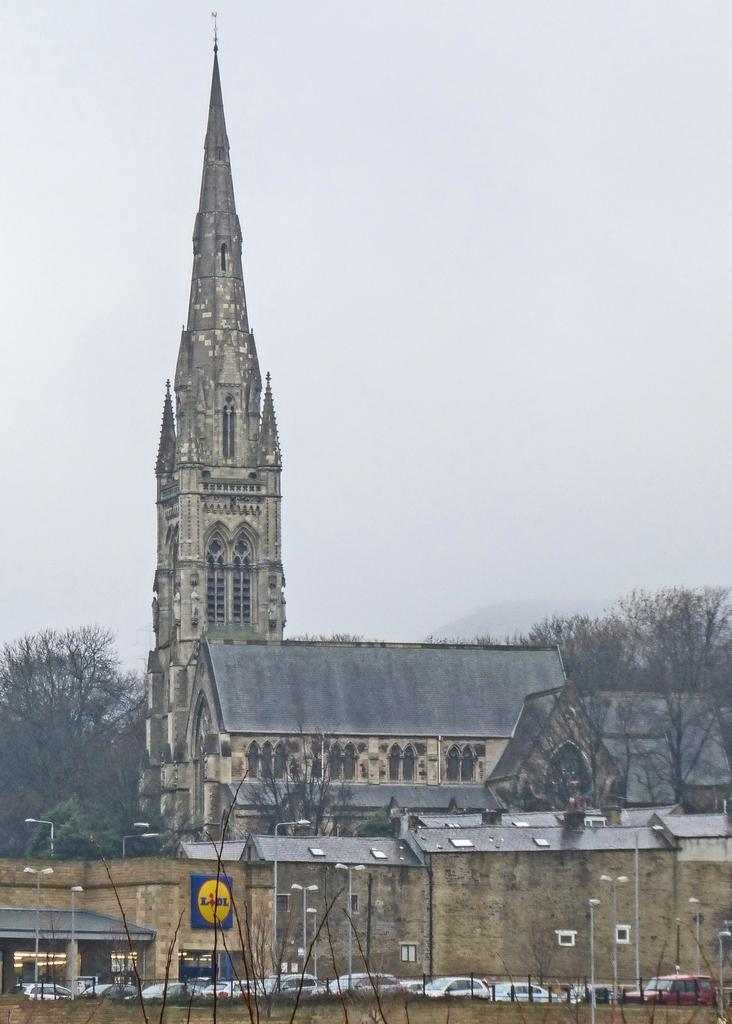What types of objects can be seen in the image? There are vehicles and light poles in the image. What can be seen in the background of the image? There are buildings, trees, and the sky visible in the background of the image. What colors are the buildings in the image? The buildings are in cream and gray colors. What is the color of the sky in the image? The sky appears to be white in color in the image. What type of cork is being used by the committee in the image? There is no committee or cork present in the image. What offer is being made by the vehicles in the image? Vehicles do not make offers; they are inanimate objects. 